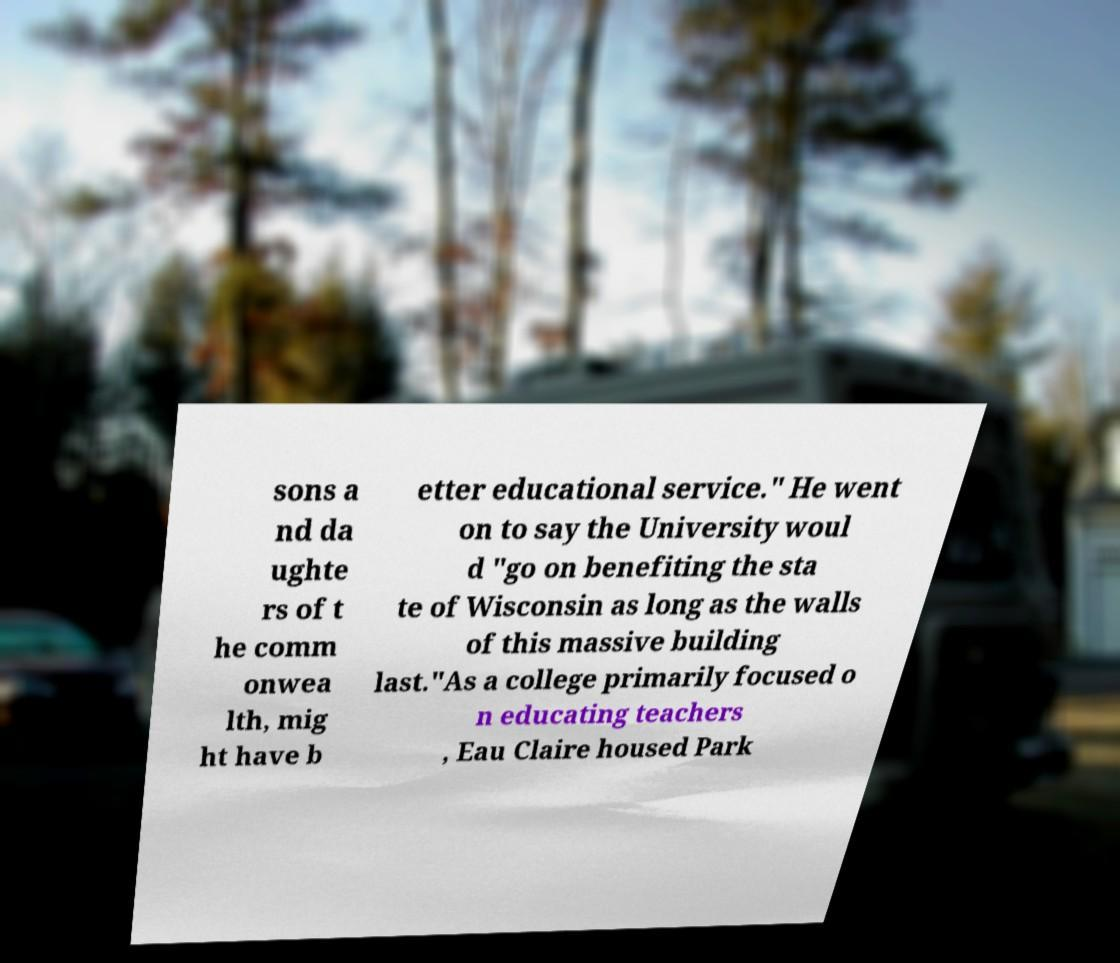I need the written content from this picture converted into text. Can you do that? sons a nd da ughte rs of t he comm onwea lth, mig ht have b etter educational service." He went on to say the University woul d "go on benefiting the sta te of Wisconsin as long as the walls of this massive building last."As a college primarily focused o n educating teachers , Eau Claire housed Park 